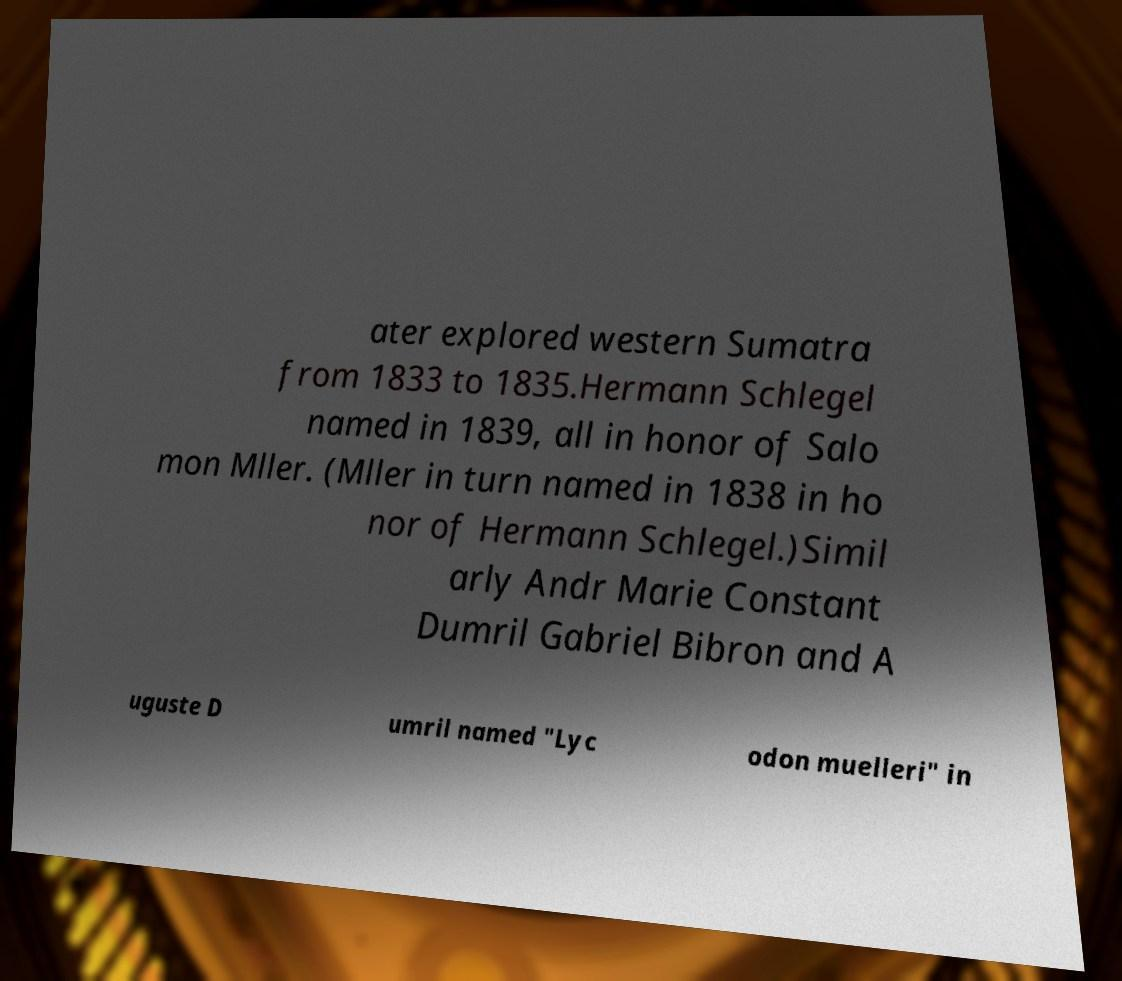Could you assist in decoding the text presented in this image and type it out clearly? ater explored western Sumatra from 1833 to 1835.Hermann Schlegel named in 1839, all in honor of Salo mon Mller. (Mller in turn named in 1838 in ho nor of Hermann Schlegel.)Simil arly Andr Marie Constant Dumril Gabriel Bibron and A uguste D umril named "Lyc odon muelleri" in 